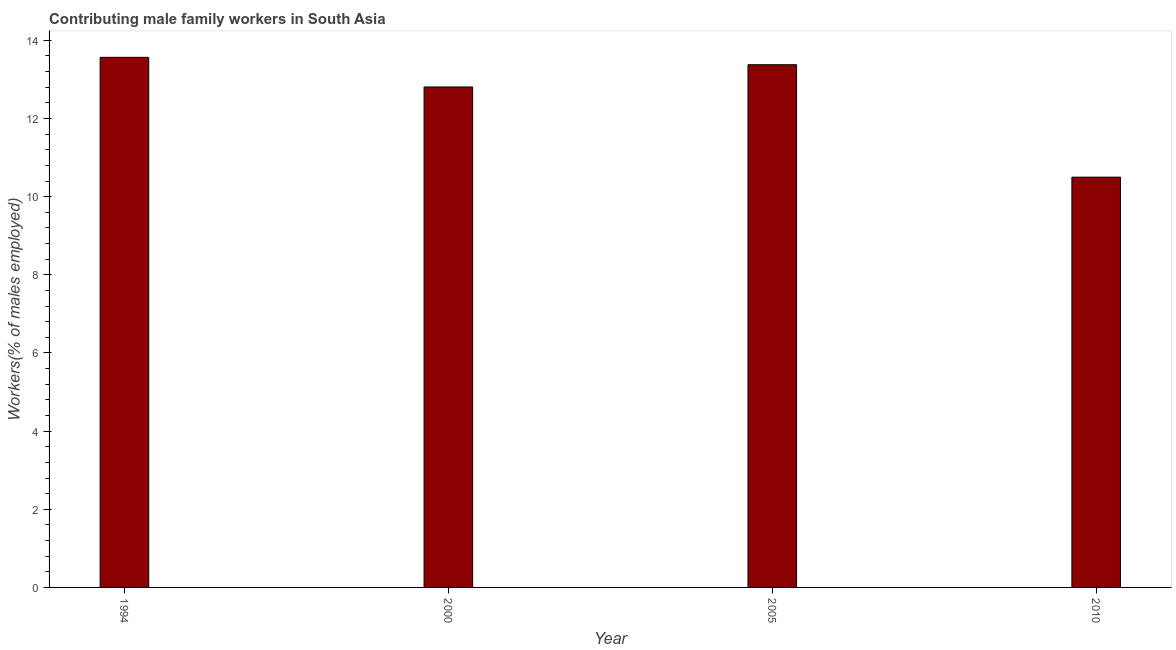Does the graph contain any zero values?
Your answer should be compact. No. What is the title of the graph?
Provide a succinct answer. Contributing male family workers in South Asia. What is the label or title of the X-axis?
Your answer should be compact. Year. What is the label or title of the Y-axis?
Give a very brief answer. Workers(% of males employed). What is the contributing male family workers in 1994?
Keep it short and to the point. 13.57. Across all years, what is the maximum contributing male family workers?
Your response must be concise. 13.57. Across all years, what is the minimum contributing male family workers?
Keep it short and to the point. 10.5. In which year was the contributing male family workers maximum?
Make the answer very short. 1994. In which year was the contributing male family workers minimum?
Ensure brevity in your answer.  2010. What is the sum of the contributing male family workers?
Offer a terse response. 50.25. What is the difference between the contributing male family workers in 1994 and 2005?
Keep it short and to the point. 0.19. What is the average contributing male family workers per year?
Your answer should be very brief. 12.56. What is the median contributing male family workers?
Offer a very short reply. 13.09. What is the ratio of the contributing male family workers in 1994 to that in 2005?
Keep it short and to the point. 1.01. Is the difference between the contributing male family workers in 1994 and 2000 greater than the difference between any two years?
Make the answer very short. No. What is the difference between the highest and the second highest contributing male family workers?
Make the answer very short. 0.19. Is the sum of the contributing male family workers in 2000 and 2005 greater than the maximum contributing male family workers across all years?
Offer a very short reply. Yes. What is the difference between the highest and the lowest contributing male family workers?
Provide a short and direct response. 3.07. How many bars are there?
Your response must be concise. 4. Are all the bars in the graph horizontal?
Your answer should be compact. No. What is the difference between two consecutive major ticks on the Y-axis?
Make the answer very short. 2. Are the values on the major ticks of Y-axis written in scientific E-notation?
Your answer should be compact. No. What is the Workers(% of males employed) of 1994?
Your response must be concise. 13.57. What is the Workers(% of males employed) of 2000?
Your response must be concise. 12.81. What is the Workers(% of males employed) of 2005?
Your answer should be compact. 13.38. What is the Workers(% of males employed) of 2010?
Offer a very short reply. 10.5. What is the difference between the Workers(% of males employed) in 1994 and 2000?
Offer a terse response. 0.76. What is the difference between the Workers(% of males employed) in 1994 and 2005?
Make the answer very short. 0.19. What is the difference between the Workers(% of males employed) in 1994 and 2010?
Give a very brief answer. 3.07. What is the difference between the Workers(% of males employed) in 2000 and 2005?
Your response must be concise. -0.57. What is the difference between the Workers(% of males employed) in 2000 and 2010?
Your answer should be compact. 2.31. What is the difference between the Workers(% of males employed) in 2005 and 2010?
Your answer should be compact. 2.88. What is the ratio of the Workers(% of males employed) in 1994 to that in 2000?
Your response must be concise. 1.06. What is the ratio of the Workers(% of males employed) in 1994 to that in 2005?
Your answer should be very brief. 1.01. What is the ratio of the Workers(% of males employed) in 1994 to that in 2010?
Offer a very short reply. 1.29. What is the ratio of the Workers(% of males employed) in 2000 to that in 2005?
Provide a short and direct response. 0.96. What is the ratio of the Workers(% of males employed) in 2000 to that in 2010?
Ensure brevity in your answer.  1.22. What is the ratio of the Workers(% of males employed) in 2005 to that in 2010?
Your answer should be compact. 1.27. 